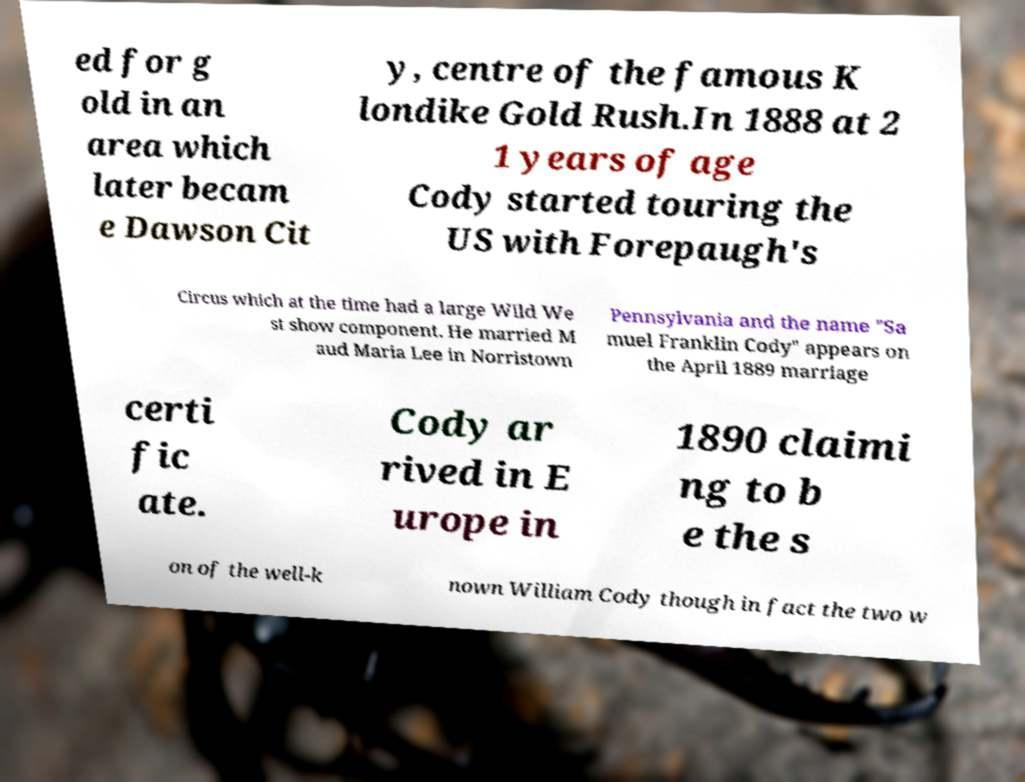Could you extract and type out the text from this image? ed for g old in an area which later becam e Dawson Cit y, centre of the famous K londike Gold Rush.In 1888 at 2 1 years of age Cody started touring the US with Forepaugh's Circus which at the time had a large Wild We st show component. He married M aud Maria Lee in Norristown Pennsylvania and the name "Sa muel Franklin Cody" appears on the April 1889 marriage certi fic ate. Cody ar rived in E urope in 1890 claimi ng to b e the s on of the well-k nown William Cody though in fact the two w 